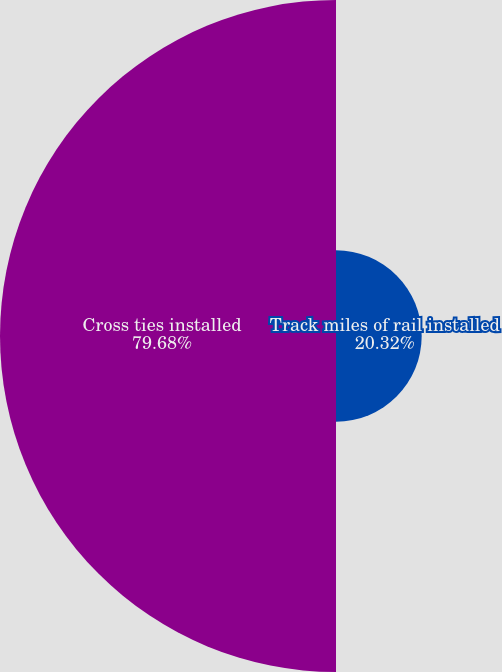Convert chart to OTSL. <chart><loc_0><loc_0><loc_500><loc_500><pie_chart><fcel>Track miles of rail installed<fcel>Cross ties installed<nl><fcel>20.32%<fcel>79.68%<nl></chart> 